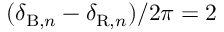<formula> <loc_0><loc_0><loc_500><loc_500>( \delta _ { B , n } - \delta _ { R , n } ) / 2 \pi = 2</formula> 